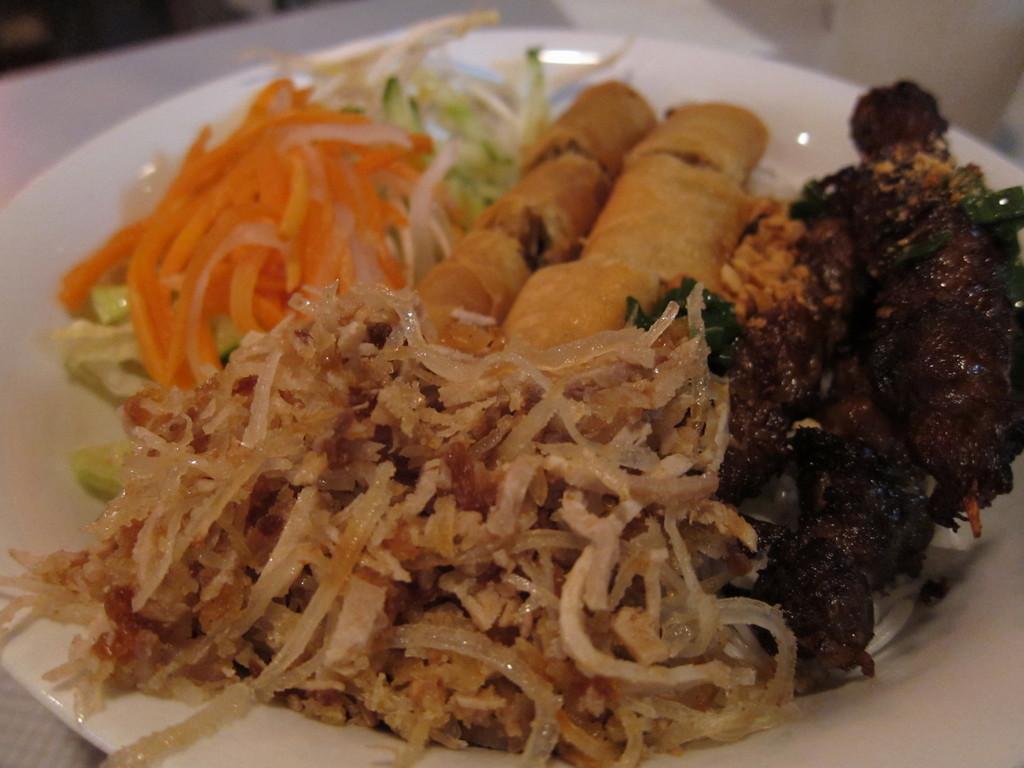Can you describe this image briefly? In the picture we can see a plate with some vegetable salads and some fried food in it. 